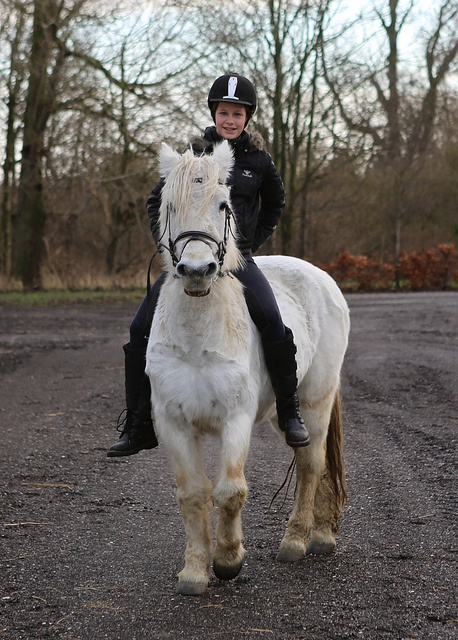Describe the objects in this image and their specific colors. I can see horse in gray, darkgray, lightgray, and black tones and people in gray and black tones in this image. 